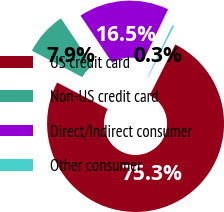Convert chart. <chart><loc_0><loc_0><loc_500><loc_500><pie_chart><fcel>US credit card<fcel>Non-US credit card<fcel>Direct/Indirect consumer<fcel>Other consumer<nl><fcel>75.26%<fcel>7.92%<fcel>16.51%<fcel>0.31%<nl></chart> 